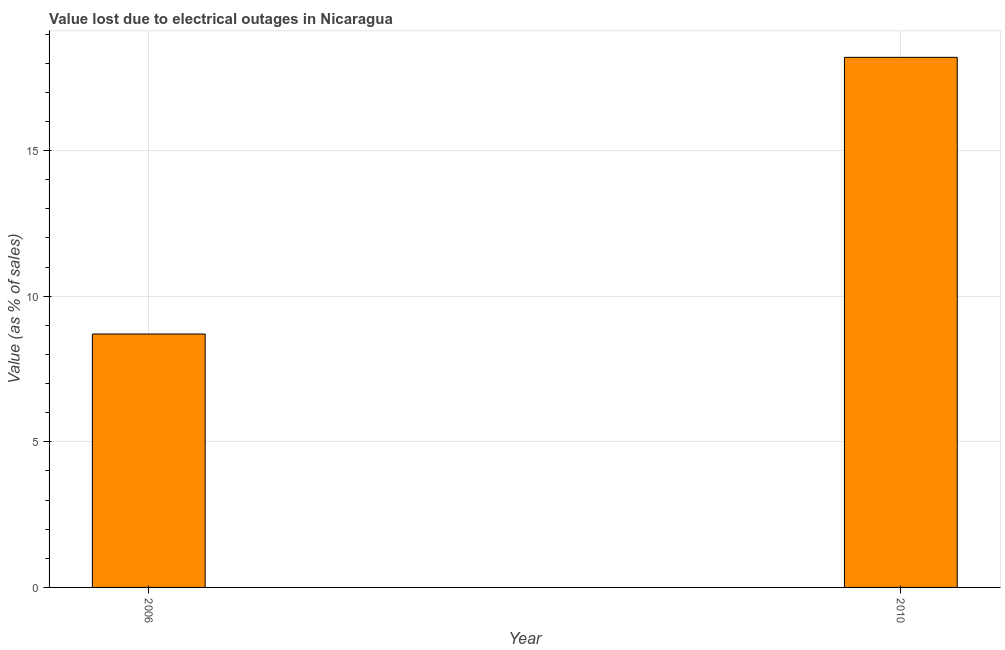What is the title of the graph?
Provide a short and direct response. Value lost due to electrical outages in Nicaragua. What is the label or title of the Y-axis?
Your response must be concise. Value (as % of sales). In which year was the value lost due to electrical outages minimum?
Make the answer very short. 2006. What is the sum of the value lost due to electrical outages?
Your answer should be compact. 26.9. What is the difference between the value lost due to electrical outages in 2006 and 2010?
Provide a succinct answer. -9.5. What is the average value lost due to electrical outages per year?
Make the answer very short. 13.45. What is the median value lost due to electrical outages?
Offer a very short reply. 13.45. In how many years, is the value lost due to electrical outages greater than 8 %?
Give a very brief answer. 2. Do a majority of the years between 2006 and 2010 (inclusive) have value lost due to electrical outages greater than 11 %?
Give a very brief answer. No. What is the ratio of the value lost due to electrical outages in 2006 to that in 2010?
Your response must be concise. 0.48. In how many years, is the value lost due to electrical outages greater than the average value lost due to electrical outages taken over all years?
Your answer should be very brief. 1. How many bars are there?
Give a very brief answer. 2. Are all the bars in the graph horizontal?
Keep it short and to the point. No. How many years are there in the graph?
Offer a terse response. 2. Are the values on the major ticks of Y-axis written in scientific E-notation?
Your answer should be compact. No. What is the Value (as % of sales) of 2006?
Make the answer very short. 8.7. What is the ratio of the Value (as % of sales) in 2006 to that in 2010?
Ensure brevity in your answer.  0.48. 